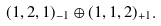Convert formula to latex. <formula><loc_0><loc_0><loc_500><loc_500>( 1 , 2 , 1 ) _ { - 1 } \oplus ( 1 , 1 , 2 ) _ { + 1 } .</formula> 